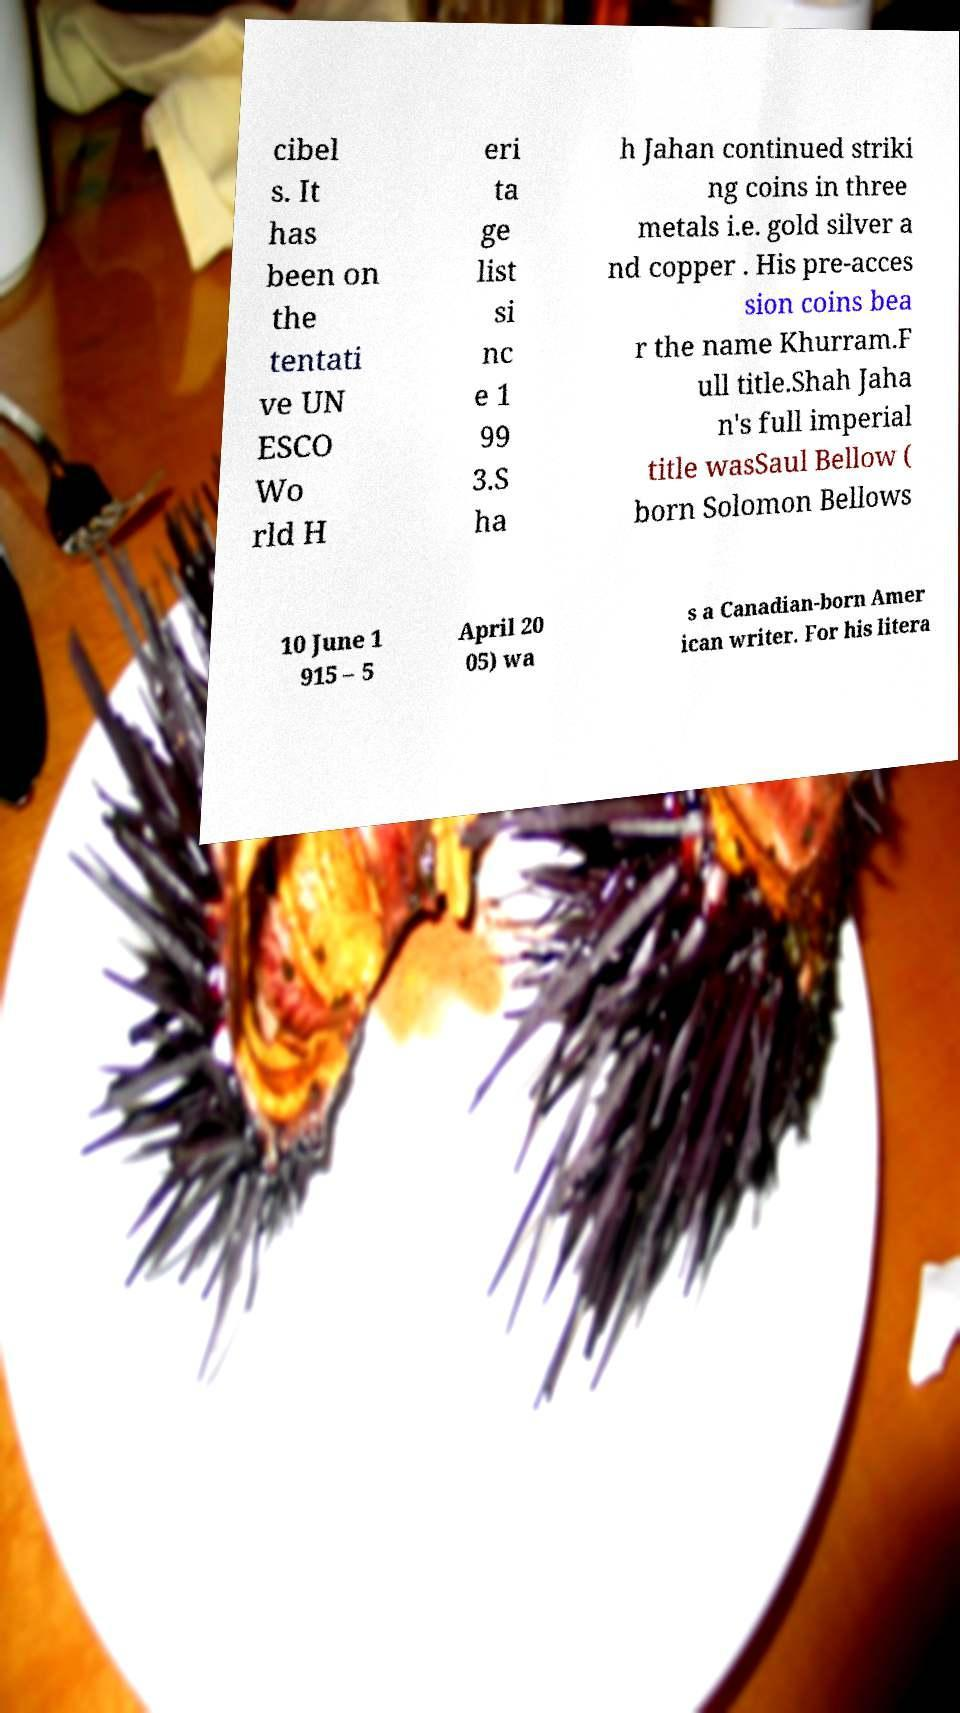Could you extract and type out the text from this image? cibel s. It has been on the tentati ve UN ESCO Wo rld H eri ta ge list si nc e 1 99 3.S ha h Jahan continued striki ng coins in three metals i.e. gold silver a nd copper . His pre-acces sion coins bea r the name Khurram.F ull title.Shah Jaha n's full imperial title wasSaul Bellow ( born Solomon Bellows 10 June 1 915 – 5 April 20 05) wa s a Canadian-born Amer ican writer. For his litera 